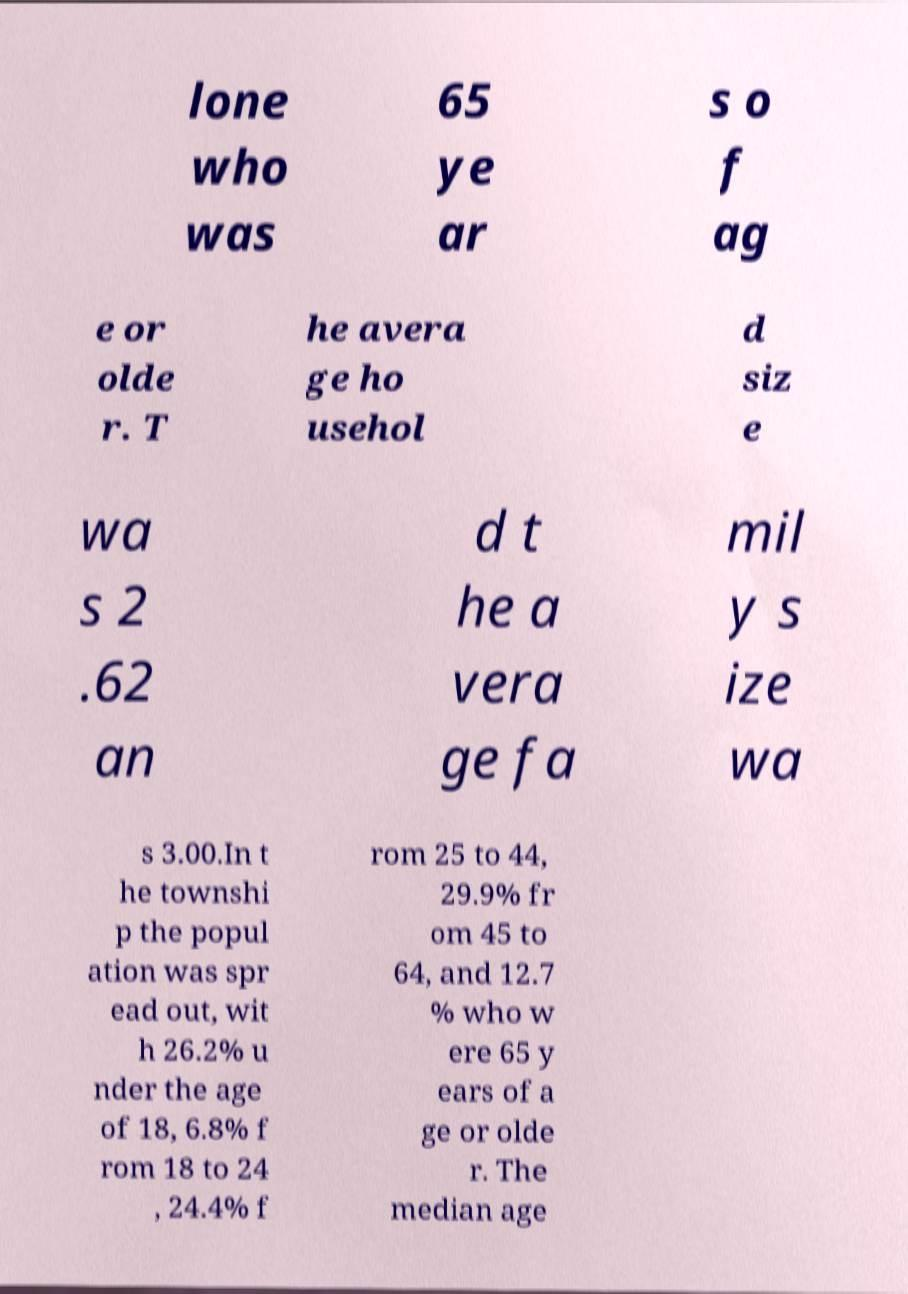I need the written content from this picture converted into text. Can you do that? lone who was 65 ye ar s o f ag e or olde r. T he avera ge ho usehol d siz e wa s 2 .62 an d t he a vera ge fa mil y s ize wa s 3.00.In t he townshi p the popul ation was spr ead out, wit h 26.2% u nder the age of 18, 6.8% f rom 18 to 24 , 24.4% f rom 25 to 44, 29.9% fr om 45 to 64, and 12.7 % who w ere 65 y ears of a ge or olde r. The median age 